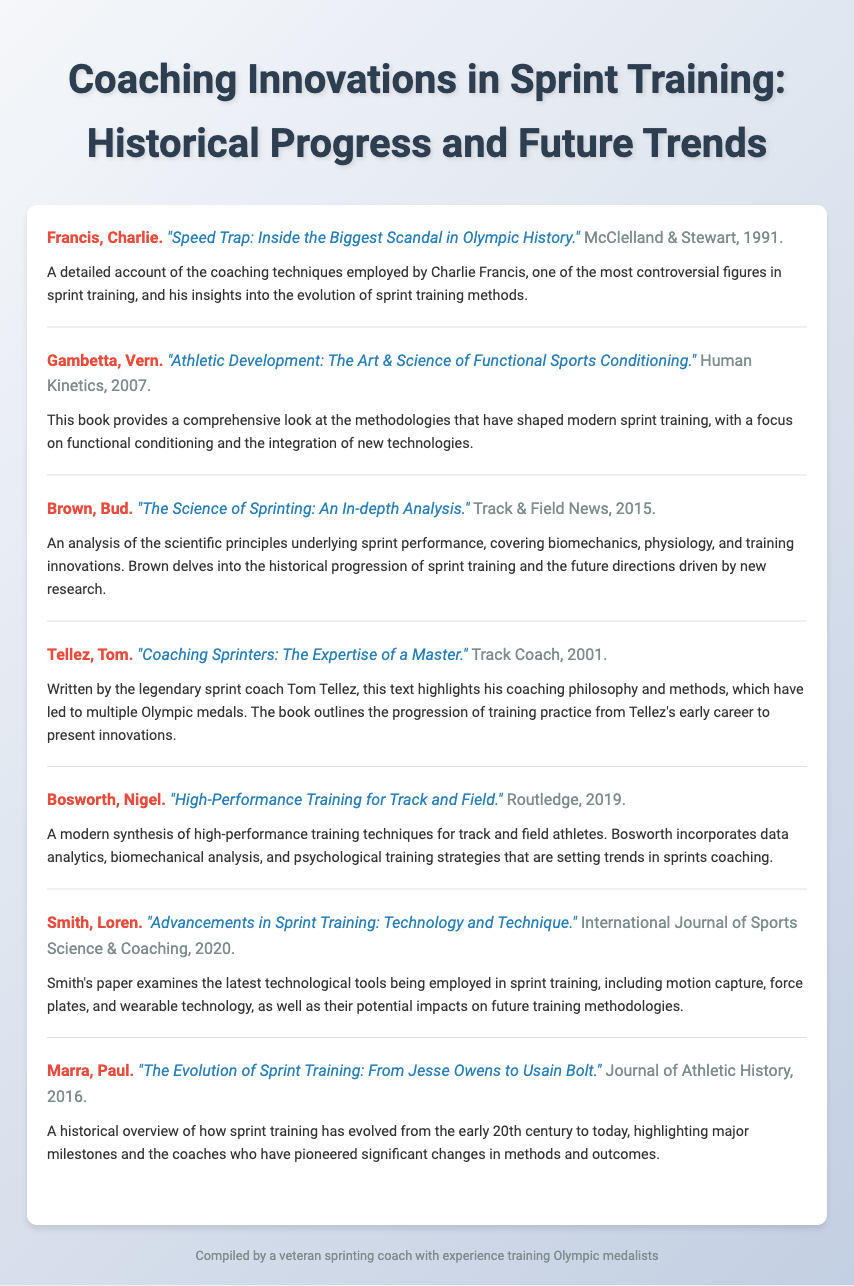What is the title of the first entry? The title of the first entry is found in the text and is "Speed Trap: Inside the Biggest Scandal in Olympic History."
Answer: "Speed Trap: Inside the Biggest Scandal in Olympic History." Who authored the book published in 2007? The author's name is presented before the title in the document for the 2007 entry, which is Vern Gambetta.
Answer: Vern Gambetta What year was "The Science of Sprinting: An In-depth Analysis" published? The publication year of this specific entry is included in the document and is 2015.
Answer: 2015 Which publisher released "High-Performance Training for Track and Field"? The publisher's name is located in the entry details and is Routledge.
Answer: Routledge What is a key focus of Smith's 2020 paper? The focus of the paper is described clearly in the document, concentrating on technological tools in sprint training.
Answer: Technological tools What distinguishes Tellez's book from others in the bibliography? Tellez's book is unique for its insights into the author's personal coaching philosophy and methods.
Answer: Coaching philosophy and methods How many years separates the publication of the first and last entries? The first entry was published in 1991, and the last in 2020, so the difference is calculated as 2020 - 1991 = 29 years.
Answer: 29 years What type of publication is "Advancements in Sprint Training: Technology and Technique"? The type of publication is indicated in the citation, which identifies it as a paper in an academic journal.
Answer: Academic journal What major theme is covered in Marra's 2016 work? The theme discussed in Marra's work pertains to the historical evolution of sprint training through key milestones.
Answer: Historical evolution of sprint training 